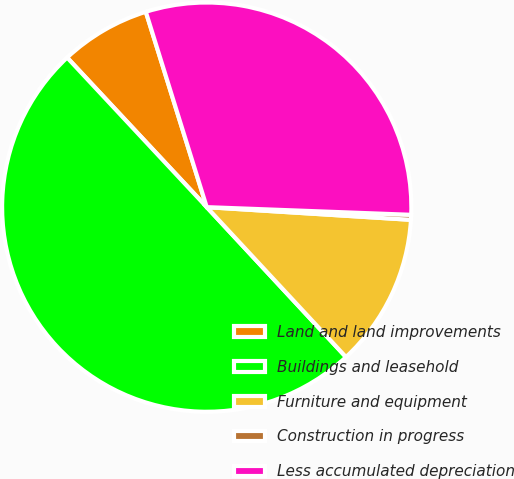Convert chart. <chart><loc_0><loc_0><loc_500><loc_500><pie_chart><fcel>Land and land improvements<fcel>Buildings and leasehold<fcel>Furniture and equipment<fcel>Construction in progress<fcel>Less accumulated depreciation<nl><fcel>7.14%<fcel>49.96%<fcel>12.1%<fcel>0.39%<fcel>30.41%<nl></chart> 